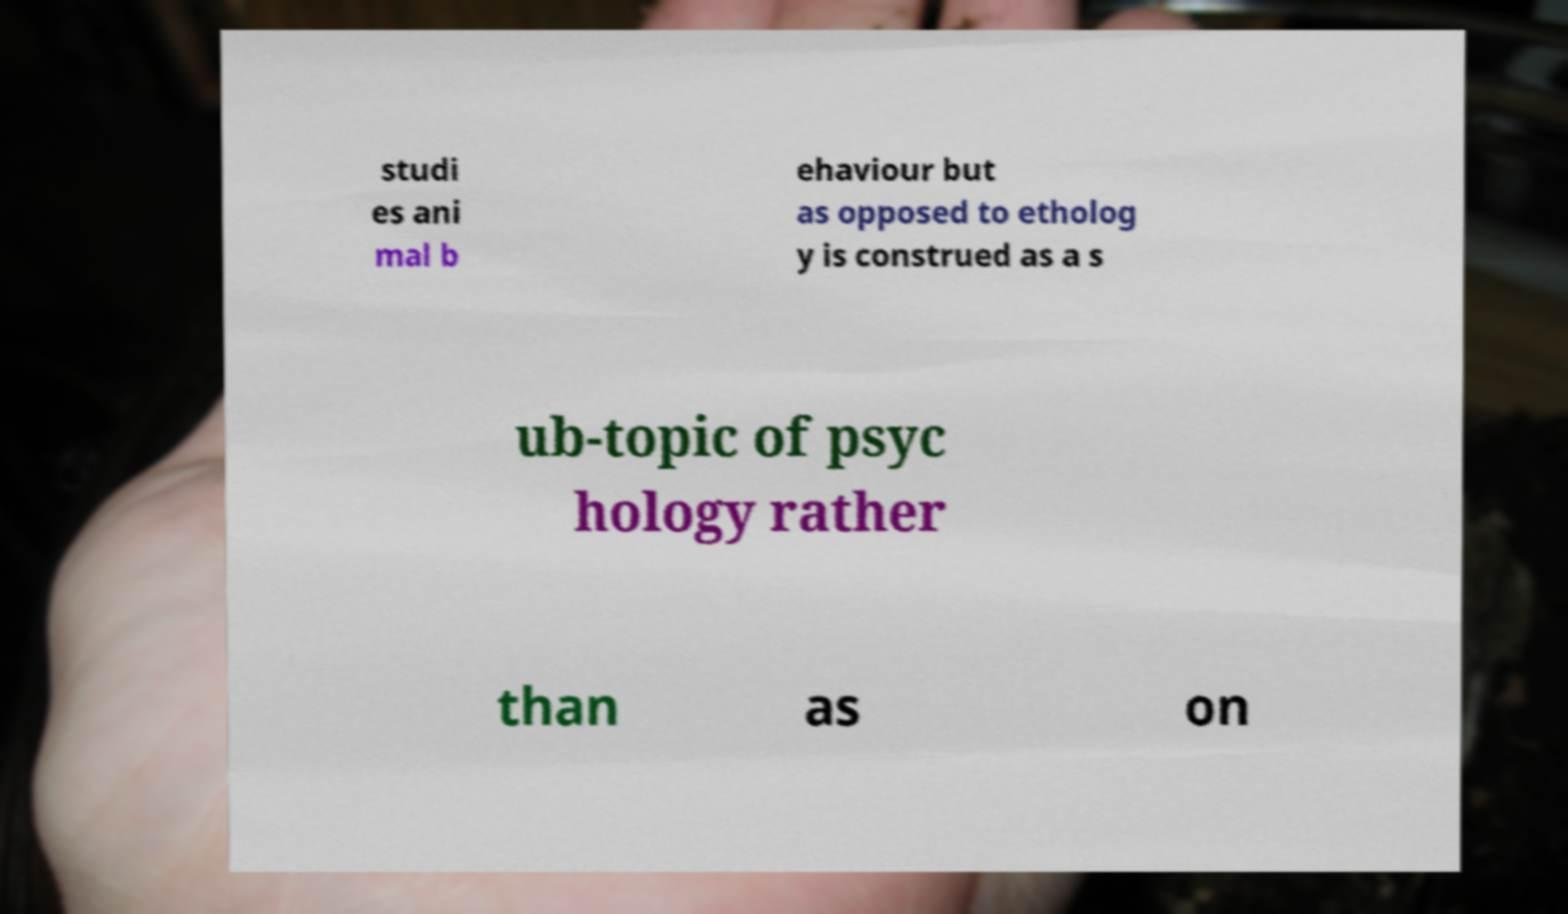I need the written content from this picture converted into text. Can you do that? studi es ani mal b ehaviour but as opposed to etholog y is construed as a s ub-topic of psyc hology rather than as on 